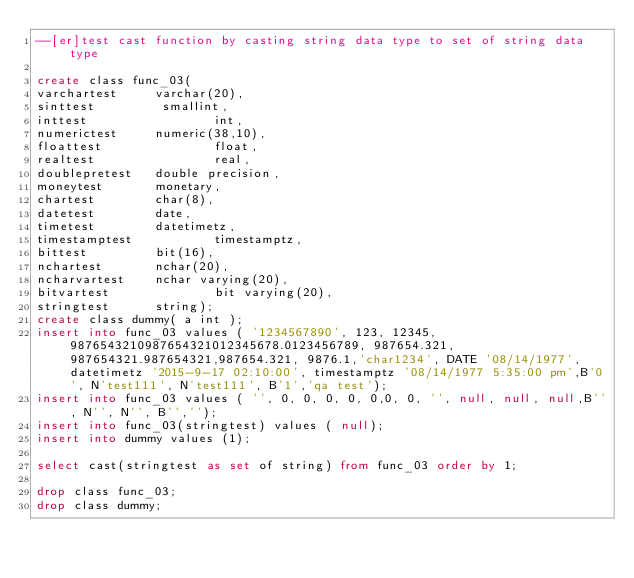<code> <loc_0><loc_0><loc_500><loc_500><_SQL_>--[er]test cast function by casting string data type to set of string data type 

create class func_03(
varchartest     varchar(20),
sinttest         smallint,
inttest                 int,
numerictest     numeric(38,10),
floattest               float,
realtest                real,
doublepretest   double precision,
moneytest       monetary,
chartest        char(8),
datetest        date,
timetest        datetimetz,
timestamptest           timestamptz,
bittest         bit(16),
nchartest       nchar(20),
ncharvartest    nchar varying(20),
bitvartest              bit varying(20),
stringtest      string);
create class dummy( a int );
insert into func_03 values ( '1234567890', 123, 12345, 9876543210987654321012345678.0123456789, 987654.321, 987654321.987654321,987654.321, 9876.1,'char1234', DATE '08/14/1977', datetimetz '2015-9-17 02:10:00', timestamptz '08/14/1977 5:35:00 pm',B'0', N'test111', N'test111', B'1','qa test');
insert into func_03 values ( '', 0, 0, 0, 0, 0,0, 0, '', null, null, null,B'', N'', N'', B'','');
insert into func_03(stringtest) values ( null);
insert into dummy values (1);

select cast(stringtest as set of string) from func_03 order by 1;

drop class func_03;
drop class dummy;
</code> 